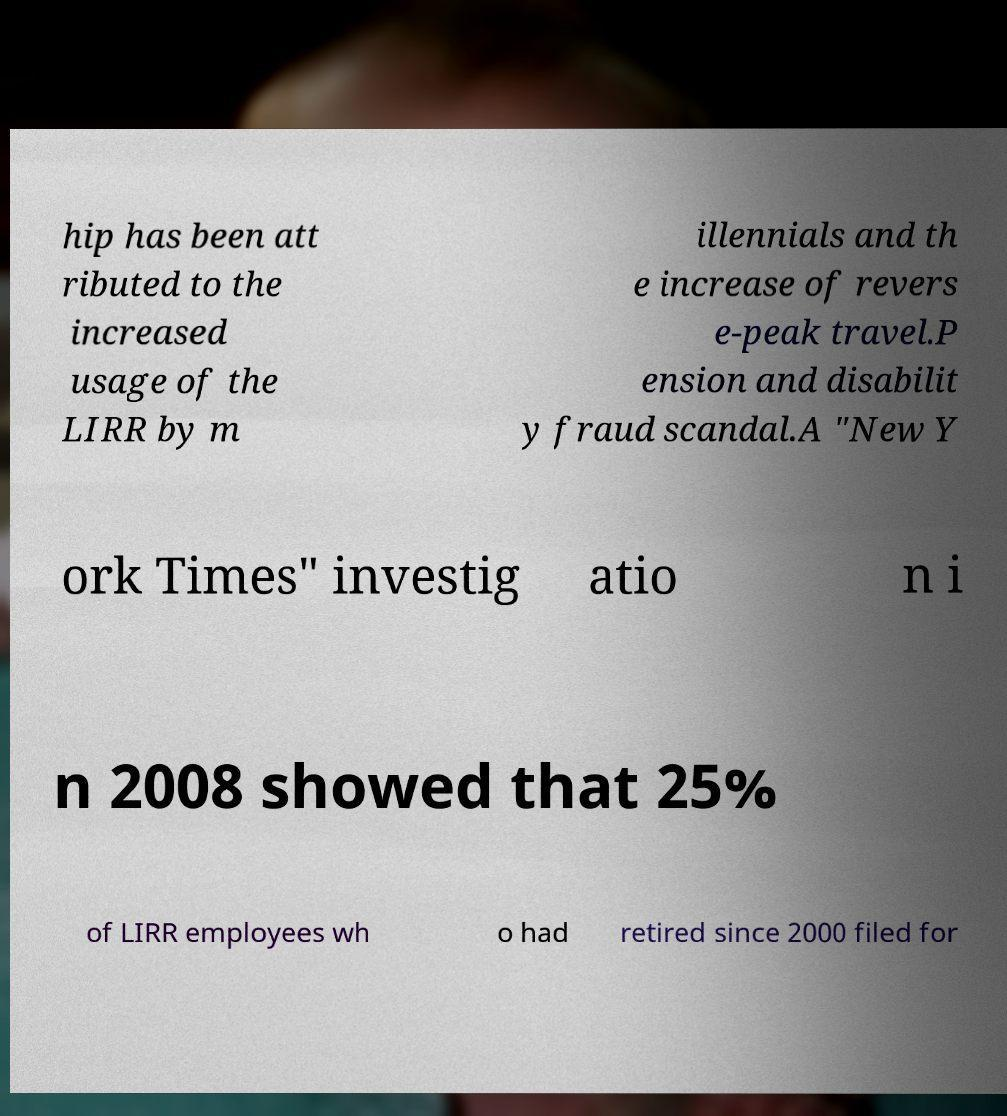There's text embedded in this image that I need extracted. Can you transcribe it verbatim? hip has been att ributed to the increased usage of the LIRR by m illennials and th e increase of revers e-peak travel.P ension and disabilit y fraud scandal.A "New Y ork Times" investig atio n i n 2008 showed that 25% of LIRR employees wh o had retired since 2000 filed for 